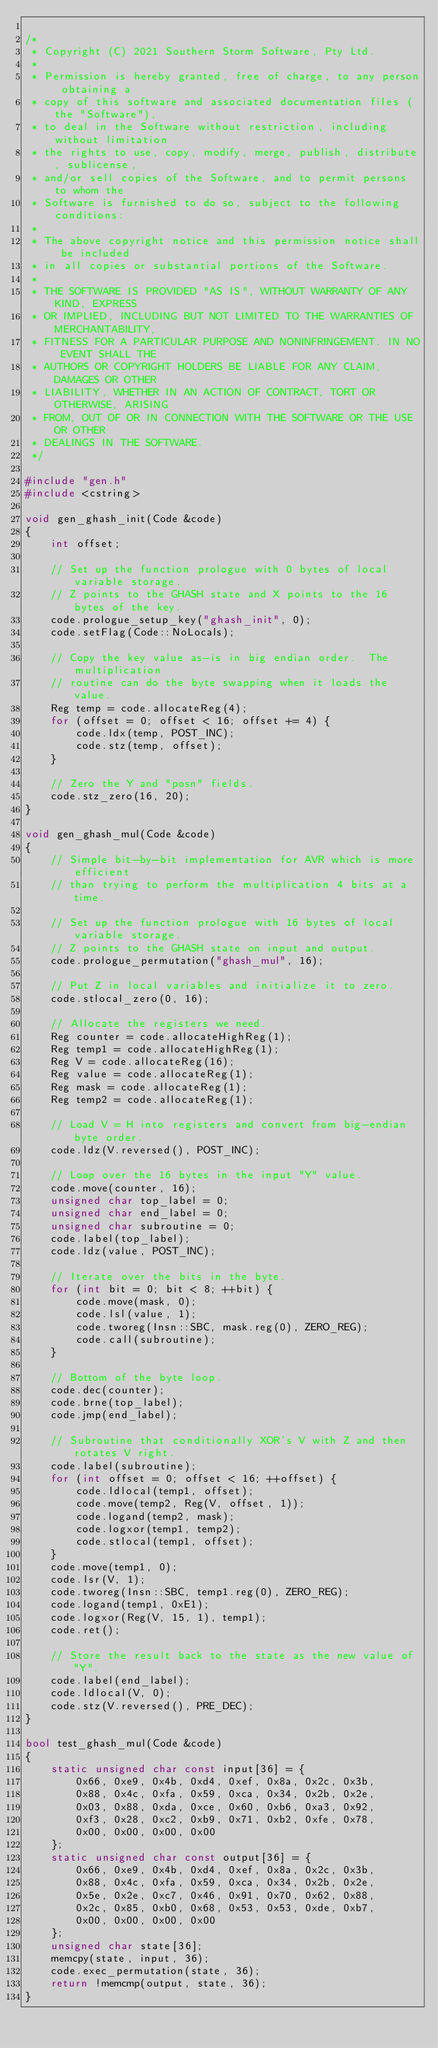<code> <loc_0><loc_0><loc_500><loc_500><_C++_>
/*
 * Copyright (C) 2021 Southern Storm Software, Pty Ltd.
 *
 * Permission is hereby granted, free of charge, to any person obtaining a
 * copy of this software and associated documentation files (the "Software"),
 * to deal in the Software without restriction, including without limitation
 * the rights to use, copy, modify, merge, publish, distribute, sublicense,
 * and/or sell copies of the Software, and to permit persons to whom the
 * Software is furnished to do so, subject to the following conditions:
 *
 * The above copyright notice and this permission notice shall be included
 * in all copies or substantial portions of the Software.
 *
 * THE SOFTWARE IS PROVIDED "AS IS", WITHOUT WARRANTY OF ANY KIND, EXPRESS
 * OR IMPLIED, INCLUDING BUT NOT LIMITED TO THE WARRANTIES OF MERCHANTABILITY,
 * FITNESS FOR A PARTICULAR PURPOSE AND NONINFRINGEMENT. IN NO EVENT SHALL THE
 * AUTHORS OR COPYRIGHT HOLDERS BE LIABLE FOR ANY CLAIM, DAMAGES OR OTHER
 * LIABILITY, WHETHER IN AN ACTION OF CONTRACT, TORT OR OTHERWISE, ARISING
 * FROM, OUT OF OR IN CONNECTION WITH THE SOFTWARE OR THE USE OR OTHER
 * DEALINGS IN THE SOFTWARE.
 */

#include "gen.h"
#include <cstring>

void gen_ghash_init(Code &code)
{
    int offset;

    // Set up the function prologue with 0 bytes of local variable storage.
    // Z points to the GHASH state and X points to the 16 bytes of the key.
    code.prologue_setup_key("ghash_init", 0);
    code.setFlag(Code::NoLocals);

    // Copy the key value as-is in big endian order.  The multiplication
    // routine can do the byte swapping when it loads the value.
    Reg temp = code.allocateReg(4);
    for (offset = 0; offset < 16; offset += 4) {
        code.ldx(temp, POST_INC);
        code.stz(temp, offset);
    }

    // Zero the Y and "posn" fields.
    code.stz_zero(16, 20);
}

void gen_ghash_mul(Code &code)
{
    // Simple bit-by-bit implementation for AVR which is more efficient
    // than trying to perform the multiplication 4 bits at a time.

    // Set up the function prologue with 16 bytes of local variable storage.
    // Z points to the GHASH state on input and output.
    code.prologue_permutation("ghash_mul", 16);

    // Put Z in local variables and initialize it to zero.
    code.stlocal_zero(0, 16);

    // Allocate the registers we need.
    Reg counter = code.allocateHighReg(1);
    Reg temp1 = code.allocateHighReg(1);
    Reg V = code.allocateReg(16);
    Reg value = code.allocateReg(1);
    Reg mask = code.allocateReg(1);
    Reg temp2 = code.allocateReg(1);

    // Load V = H into registers and convert from big-endian byte order.
    code.ldz(V.reversed(), POST_INC);

    // Loop over the 16 bytes in the input "Y" value.
    code.move(counter, 16);
    unsigned char top_label = 0;
    unsigned char end_label = 0;
    unsigned char subroutine = 0;
    code.label(top_label);
    code.ldz(value, POST_INC);

    // Iterate over the bits in the byte.
    for (int bit = 0; bit < 8; ++bit) {
        code.move(mask, 0);
        code.lsl(value, 1);
        code.tworeg(Insn::SBC, mask.reg(0), ZERO_REG);
        code.call(subroutine);
    }

    // Bottom of the byte loop.
    code.dec(counter);
    code.brne(top_label);
    code.jmp(end_label);

    // Subroutine that conditionally XOR's V with Z and then rotates V right.
    code.label(subroutine);
    for (int offset = 0; offset < 16; ++offset) {
        code.ldlocal(temp1, offset);
        code.move(temp2, Reg(V, offset, 1));
        code.logand(temp2, mask);
        code.logxor(temp1, temp2);
        code.stlocal(temp1, offset);
    }
    code.move(temp1, 0);
    code.lsr(V, 1);
    code.tworeg(Insn::SBC, temp1.reg(0), ZERO_REG);
    code.logand(temp1, 0xE1);
    code.logxor(Reg(V, 15, 1), temp1);
    code.ret();

    // Store the result back to the state as the new value of "Y".
    code.label(end_label);
    code.ldlocal(V, 0);
    code.stz(V.reversed(), PRE_DEC);
}

bool test_ghash_mul(Code &code)
{
    static unsigned char const input[36] = {
        0x66, 0xe9, 0x4b, 0xd4, 0xef, 0x8a, 0x2c, 0x3b,
        0x88, 0x4c, 0xfa, 0x59, 0xca, 0x34, 0x2b, 0x2e,
        0x03, 0x88, 0xda, 0xce, 0x60, 0xb6, 0xa3, 0x92,
        0xf3, 0x28, 0xc2, 0xb9, 0x71, 0xb2, 0xfe, 0x78,
        0x00, 0x00, 0x00, 0x00
    };
    static unsigned char const output[36] = {
        0x66, 0xe9, 0x4b, 0xd4, 0xef, 0x8a, 0x2c, 0x3b,
        0x88, 0x4c, 0xfa, 0x59, 0xca, 0x34, 0x2b, 0x2e,
        0x5e, 0x2e, 0xc7, 0x46, 0x91, 0x70, 0x62, 0x88,
        0x2c, 0x85, 0xb0, 0x68, 0x53, 0x53, 0xde, 0xb7,
        0x00, 0x00, 0x00, 0x00
    };
    unsigned char state[36];
    memcpy(state, input, 36);
    code.exec_permutation(state, 36);
    return !memcmp(output, state, 36);
}
</code> 